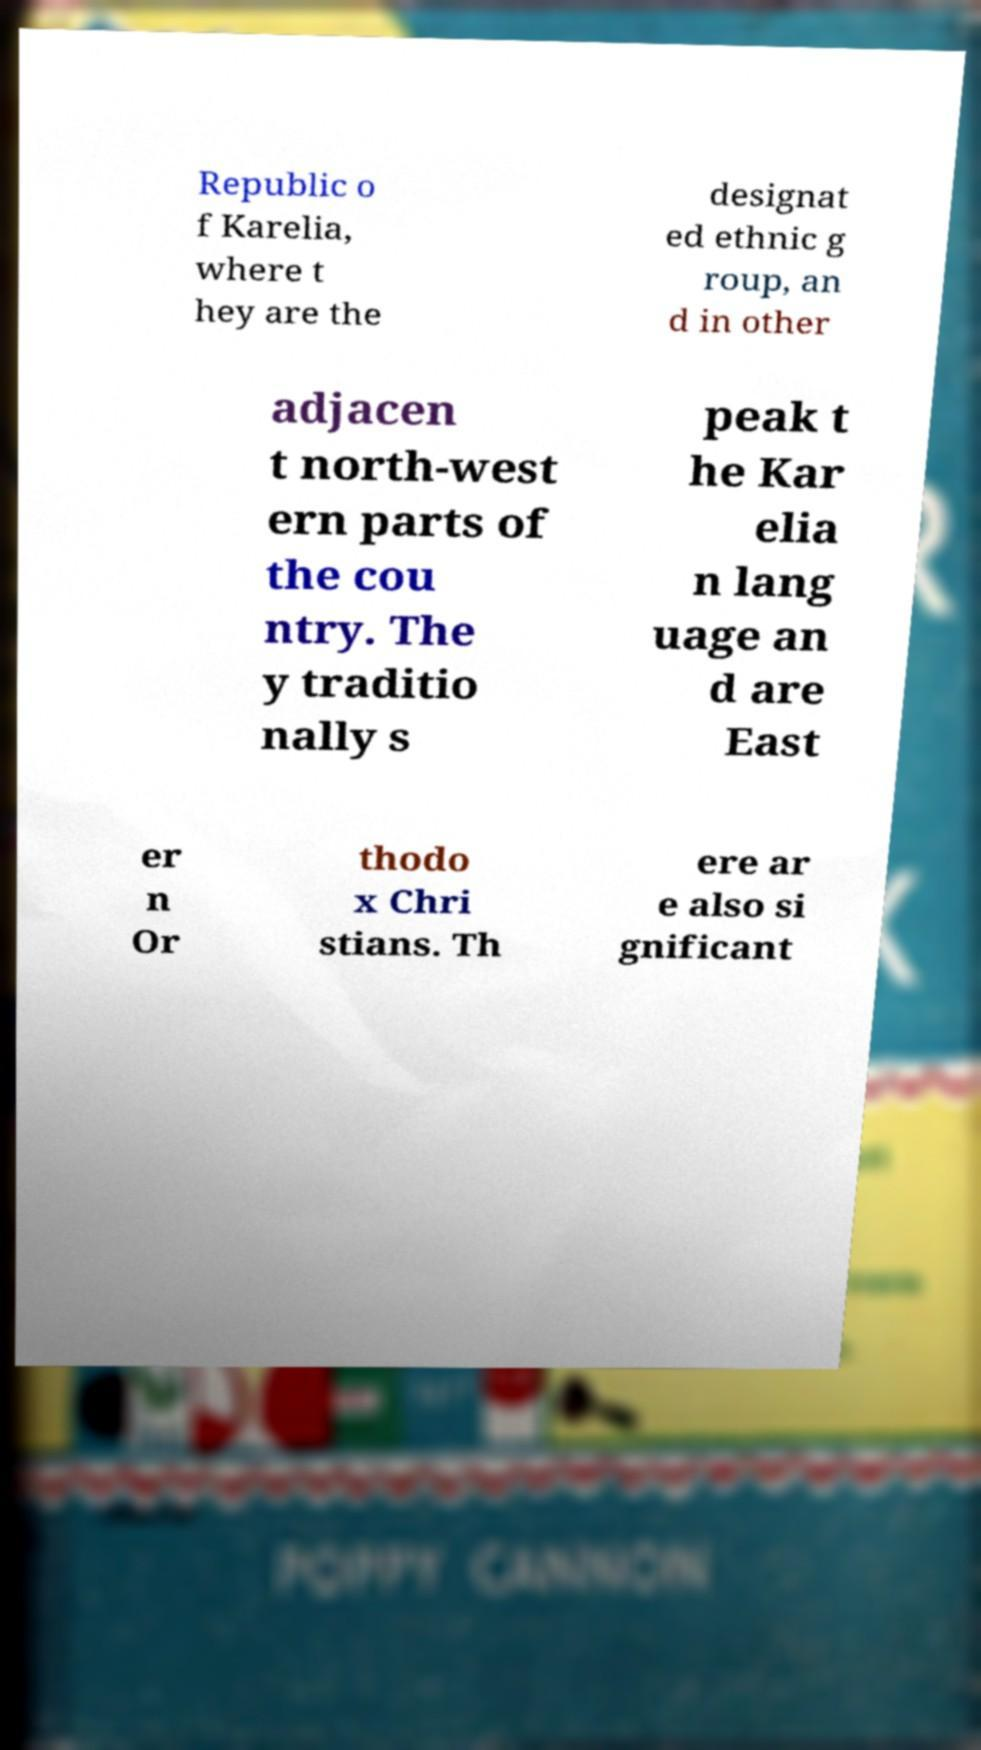For documentation purposes, I need the text within this image transcribed. Could you provide that? Republic o f Karelia, where t hey are the designat ed ethnic g roup, an d in other adjacen t north-west ern parts of the cou ntry. The y traditio nally s peak t he Kar elia n lang uage an d are East er n Or thodo x Chri stians. Th ere ar e also si gnificant 